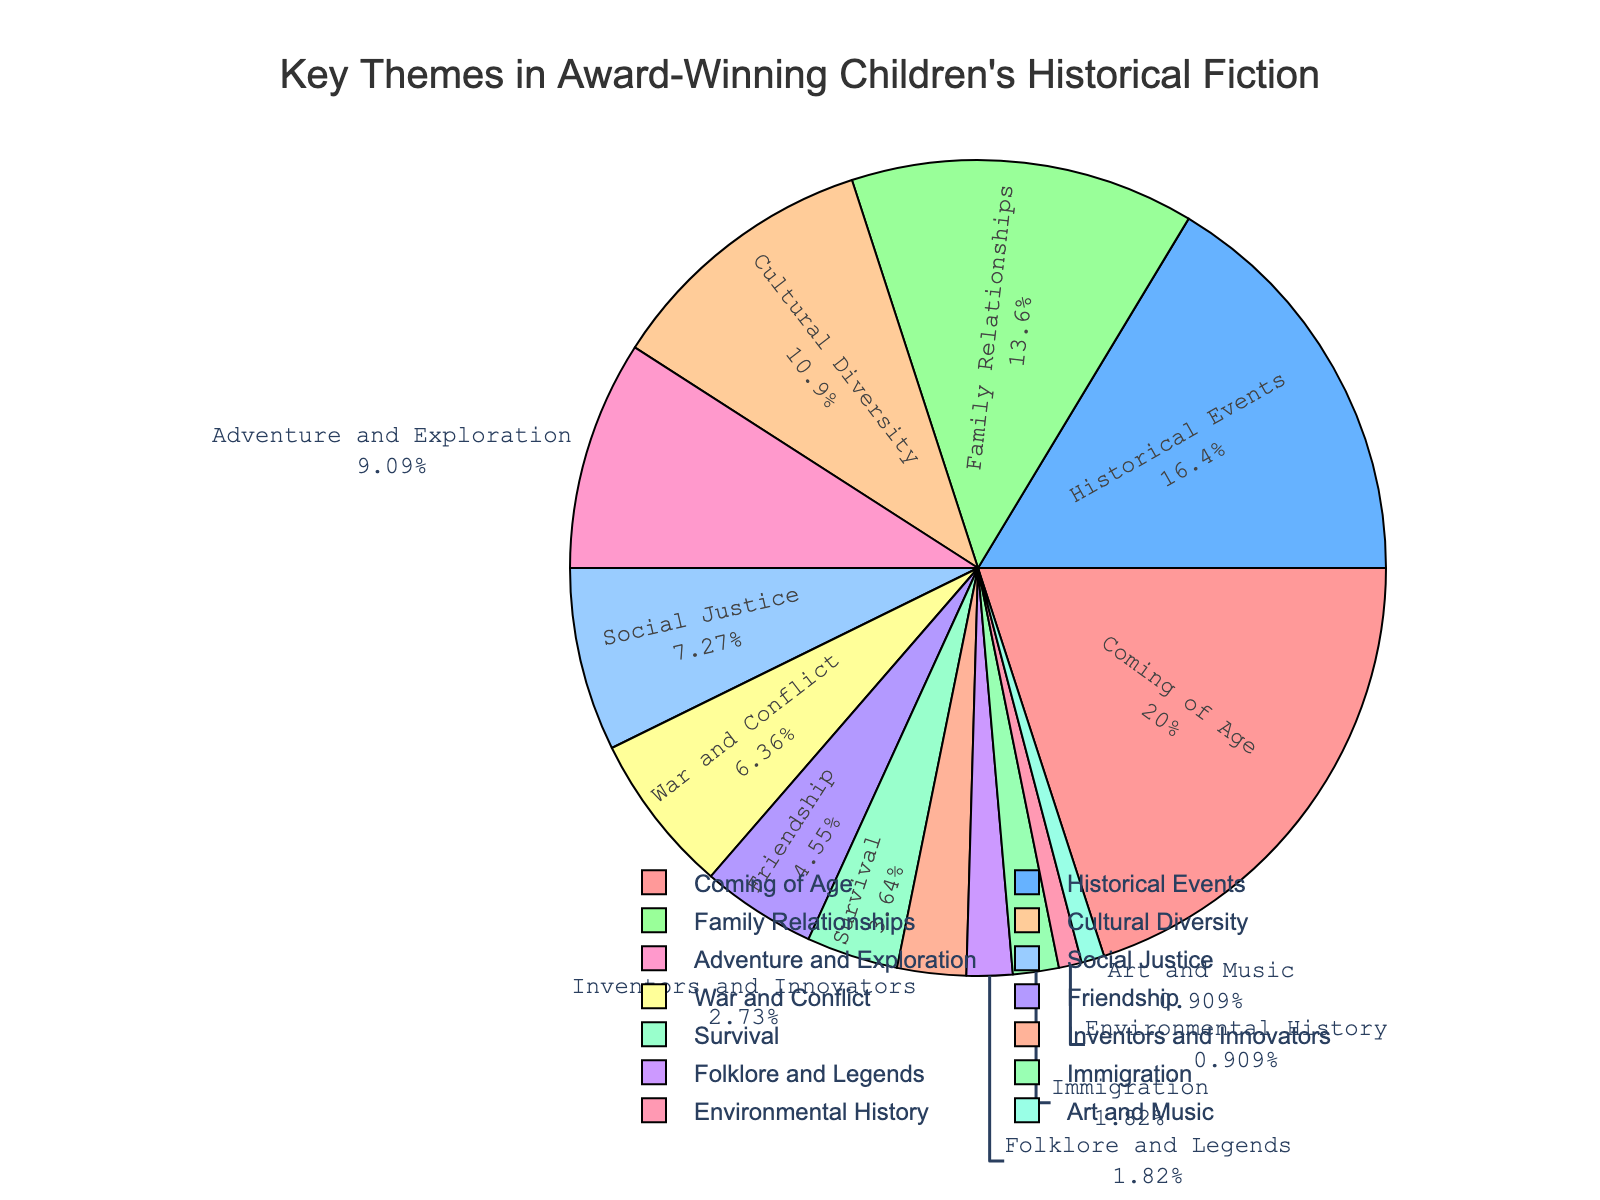Which theme has the highest percentage? The pie chart shows that "Coming of Age" has the largest section at 22%.
Answer: Coming of Age Which themes have a percentage lower than 5%? The pie chart shows that "Friendship" (5%), "Survival" (4%), "Inventors and Innovators" (3%), "Folklore and Legends" (2%), "Immigration" (2%), "Environmental History" (1%), and "Art and Music" (1%) are all below 5%.
Answer: Friendship, Survival, Inventors and Innovators, Folklore and Legends, Immigration, Environmental History, Art and Music How much larger is the "Coming of Age" section compared to "War and Conflict"? "Coming of Age" is 22% and "War and Conflict" is 7%, so the difference is 22% - 7% = 15%.
Answer: 15% What is the total percentage for Family Relationships and Cultural Diversity combined? "Family Relationships" is 15% and "Cultural Diversity" is 12%, so the sum is 15% + 12% = 27%.
Answer: 27% What is the smallest theme represented in the chart? The pie chart shows that "Environmental History" and "Art and Music" are the smallest, each at 1%.
Answer: Environmental History, Art and Music Which themes are greater than 10% but less than 20%? The pie chart shows that "Historical Events" (18%), "Family Relationships" (15%), and "Cultural Diversity" (12%) fall within this range.
Answer: Historical Events, Family Relationships, Cultural Diversity How many themes have a percentage higher than "Social Justice"? "Social Justice" is listed at 8%. Themes higher than this are "Coming of Age" (22%), "Historical Events" (18%), "Family Relationships" (15%), "Cultural Diversity" (12%), and "Adventure and Exploration" (10%), totaling 5 themes.
Answer: 5 Which theme has the same percentage as "Folklore and Legends"? The pie chart indicates that both "Folklore and Legends" and "Immigration" each have a percentage of 2%.
Answer: Immigration What is the combined percentage of the themes that are related to historical events? "Historical Events" is 18%, "War and Conflict" is 7%, "Immigration" is 2%, and "Environmental History" is 1%. The combined percentage is 18% + 7% + 2% + 1% = 28%.
Answer: 28% How does the percentage of "Adventure and Exploration" compare to that of "Friendship"? "Adventure and Exploration" is 10%, and "Friendship" is 5%; thus, "Adventure and Exploration" is double the percentage of "Friendship".
Answer: Double 